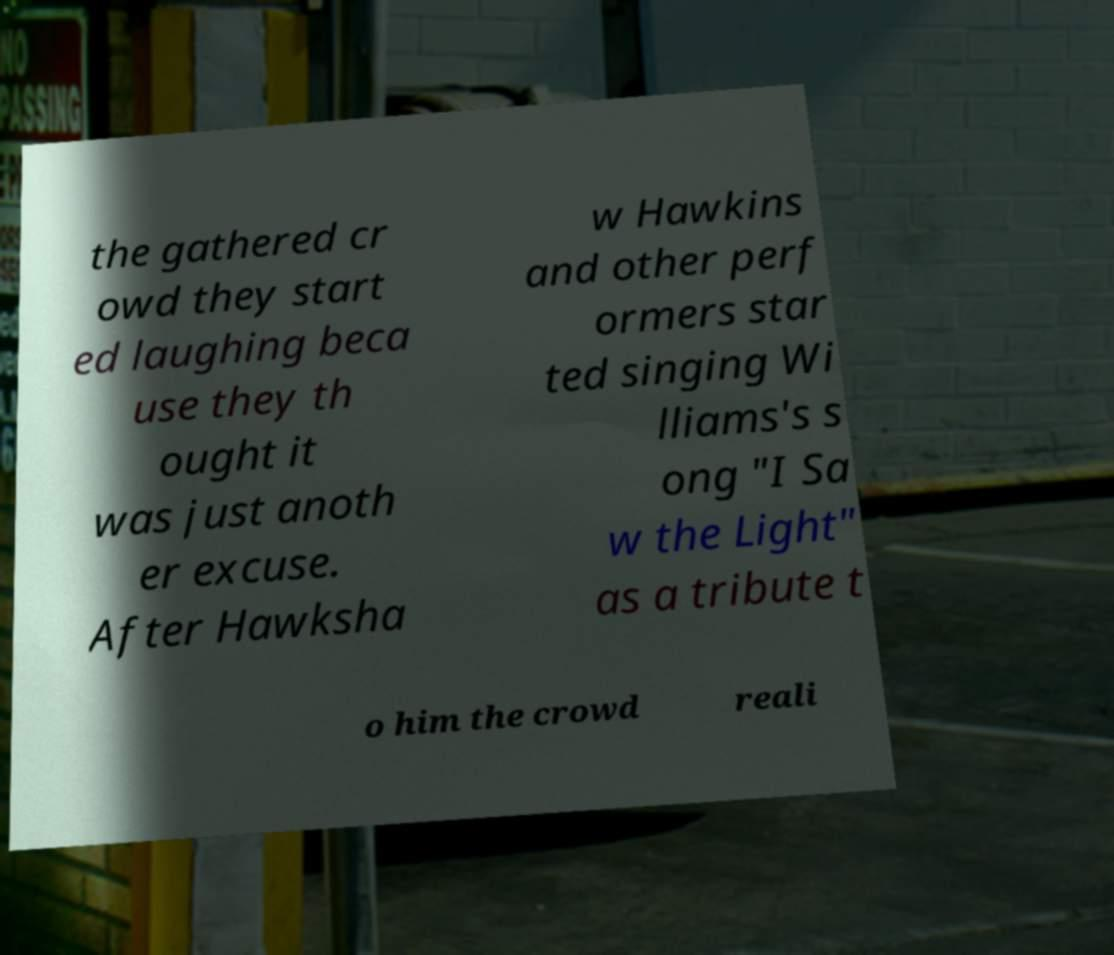Please read and relay the text visible in this image. What does it say? the gathered cr owd they start ed laughing beca use they th ought it was just anoth er excuse. After Hawksha w Hawkins and other perf ormers star ted singing Wi lliams's s ong "I Sa w the Light" as a tribute t o him the crowd reali 